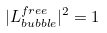<formula> <loc_0><loc_0><loc_500><loc_500>| L _ { b u b b l e } ^ { f r e e } | ^ { 2 } = 1</formula> 